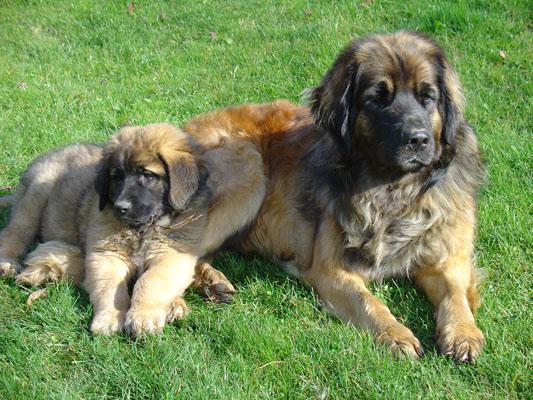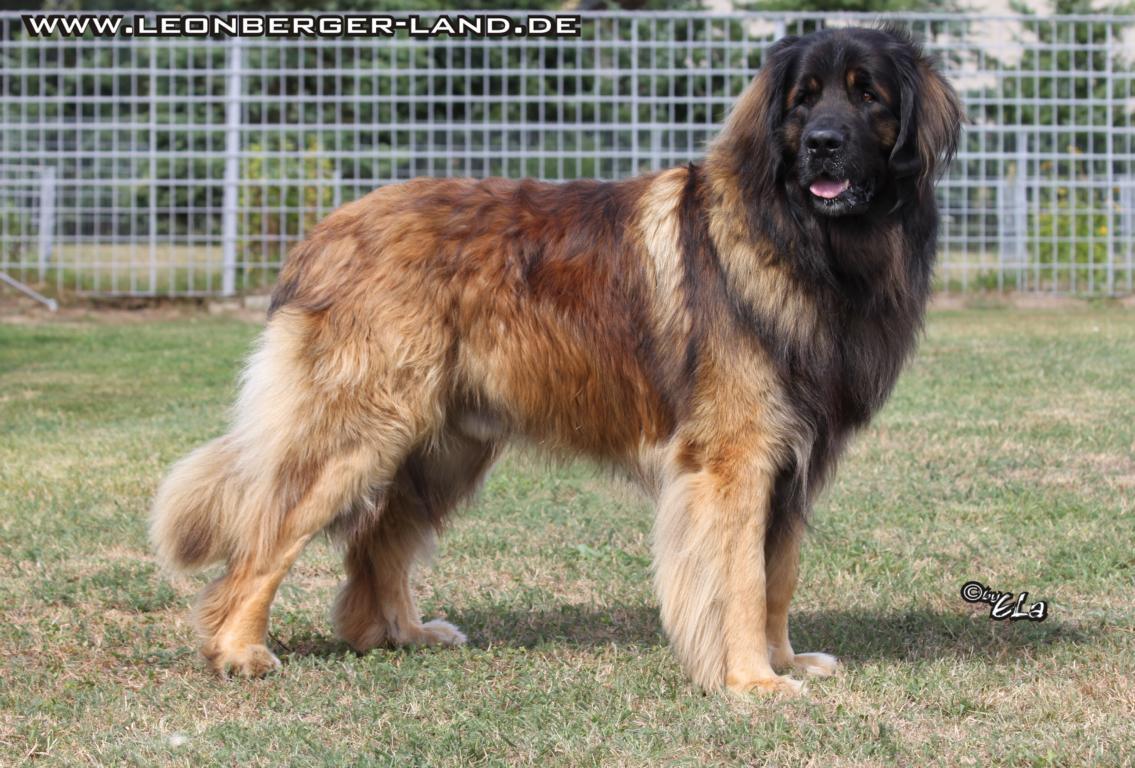The first image is the image on the left, the second image is the image on the right. Analyze the images presented: Is the assertion "There are at least three dogs  outside." valid? Answer yes or no. Yes. The first image is the image on the left, the second image is the image on the right. Evaluate the accuracy of this statement regarding the images: "Each image contains exactly one dog, which is standing in profile.". Is it true? Answer yes or no. No. 